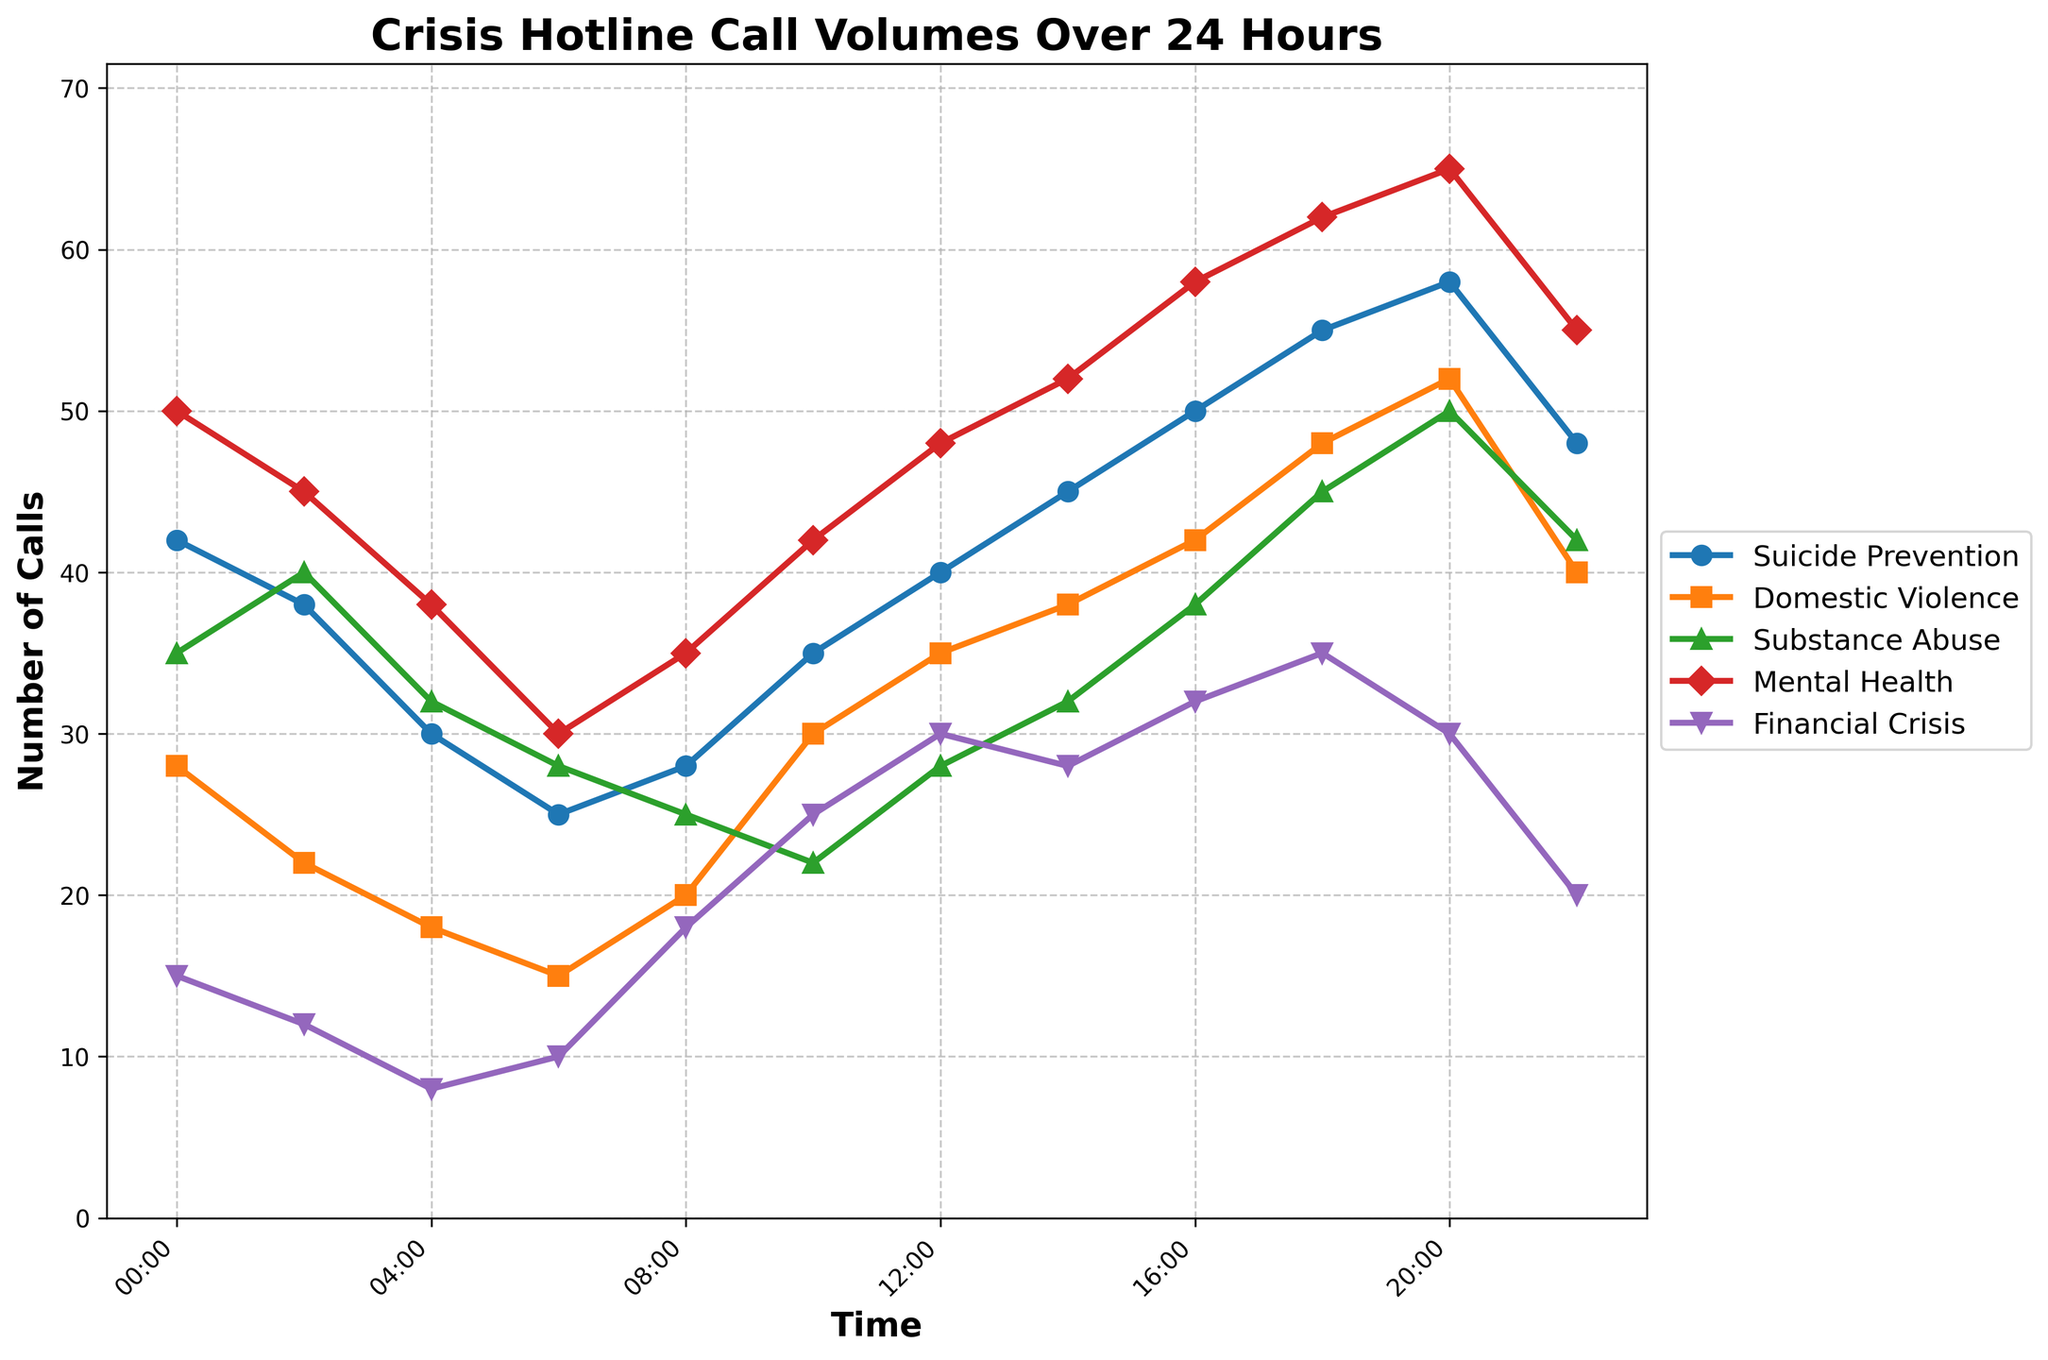What is the overall trend in suicide prevention calls throughout the 24-hour period? Examine the line for suicide prevention calls; it starts from 42 at 00:00 and generally increases, reaching a peak of 58 at 20:00 before a slight decline by 22:00. The overall trend is an increase.
Answer: Increasing At which specific time do mental health calls peak, and what is the call volume at that time? Look at the mental health line and identify its highest point. The peak occurs at 20:00 with a call volume of 65.
Answer: 20:00, 65 Compare the call volumes for domestic violence and substance abuse at 18:00. Which type of crisis has more calls, and what is the difference in their volumes? At 18:00, domestic violence has 48 calls and substance abuse has 45 calls. The difference is 48 - 45 = 3.
Answer: Domestic violence, 3 What's the average number of calls for financial crises between 00:00 and 12:00? Add the call volumes for financial crises at 00:00, 02:00, 04:00, 06:00, 08:00, 10:00, and 12:00 (15 + 12 + 8 + 10 + 18 + 25 + 30) and divide by 7. The average is (15 + 12 + 8 + 10 + 18 + 25 + 30) / 7 = 118 / 7 = 16.86.
Answer: 16.86 Are there any times when the number of substance abuse calls is equal to the number of suicide prevention calls? If yes, at which times? Compare the value of substance abuse and suicide prevention lines at all given times. Substance abuse never equals suicide prevention calls exactly at any time.
Answer: No What is the difference between the maximum and minimum number of calls for mental health crises across the 24 hours? The maximum number of mental health calls is 65 at 20:00, and the minimum is 30 at 06:00. The difference is 65 - 30 = 35.
Answer: 35 During which two-hour period do all types of crises except financial crises experience a decrease in calls? Observe the change in call volumes between each two-hour period. Between 00:00 and 02:00, all except financial crises decrease: Suicide Prevention (42 to 38), Domestic Violence (28 to 22), Substance Abuse (35 to 40), Mental Health (50 to 45).
Answer: 00:00 to 02:00 How does the call volume for suicide prevention at 12:00 compare to the call volume for domestic violence at 16:00? Suicide prevention at 12:00 has 40 calls, and domestic violence at 16:00 has 42 calls. Domestic violence has more calls by 2.
Answer: Domestic violence has 2 more Which type of crisis has the lowest peak call volume, and what is that volume? Compare the peak values of all crises. The financial crisis has the lowest peak volume at 30 calls.
Answer: Financial Crisis, 30 What time interval sees the most significant increase in mental health calls, and what is the change in call volume? Find the time interval with maximum increase in mental health calls. From 16:00 (58 calls) to 18:00 (62 calls), the change is 62 - 58 = 4 calls, the highest increase.
Answer: 16:00 to 18:00, 4 